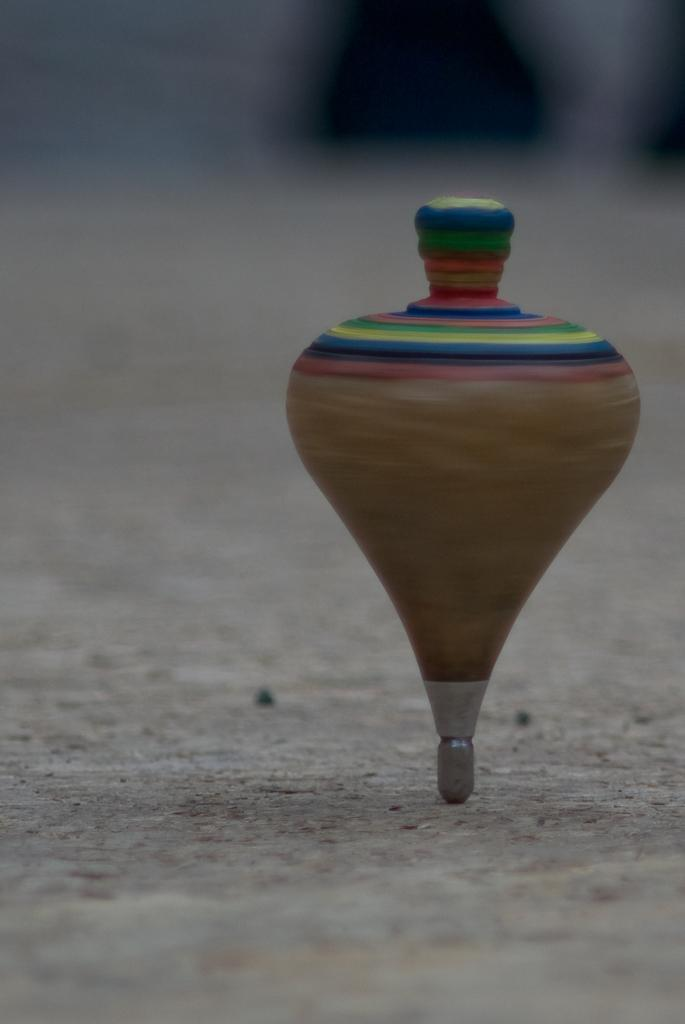What object is on the ground in the image? There is a spinning top on the ground. Can you describe the background of the image? The background of the image is blurred. How many cows are visible in the image? There are no cows present in the image. What type of tooth is being used to play with the spinning top in the image? There is no tooth present in the image, and the spinning top is not being played with using a tooth. 